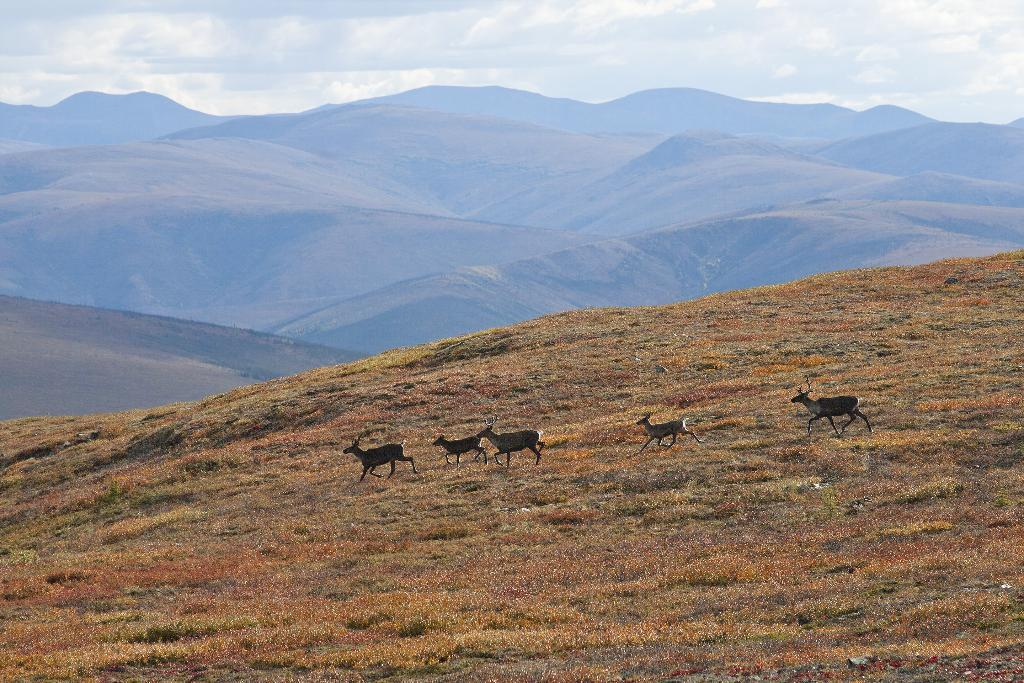What type of vegetation is present at the bottom of the image? There is grass on the ground at the bottom of the image. What can be seen in the background of the image? There are animals and mountains in the background of the image. What is visible in the sky in the background of the image? There are clouds in the sky in the background of the image. What type of club is being used to hit the ball in the image? There is no ball or club present in the image. What idea is being discussed by the animals in the image? There is no indication of a discussion or idea in the image; it only shows animals and mountains in the background. 